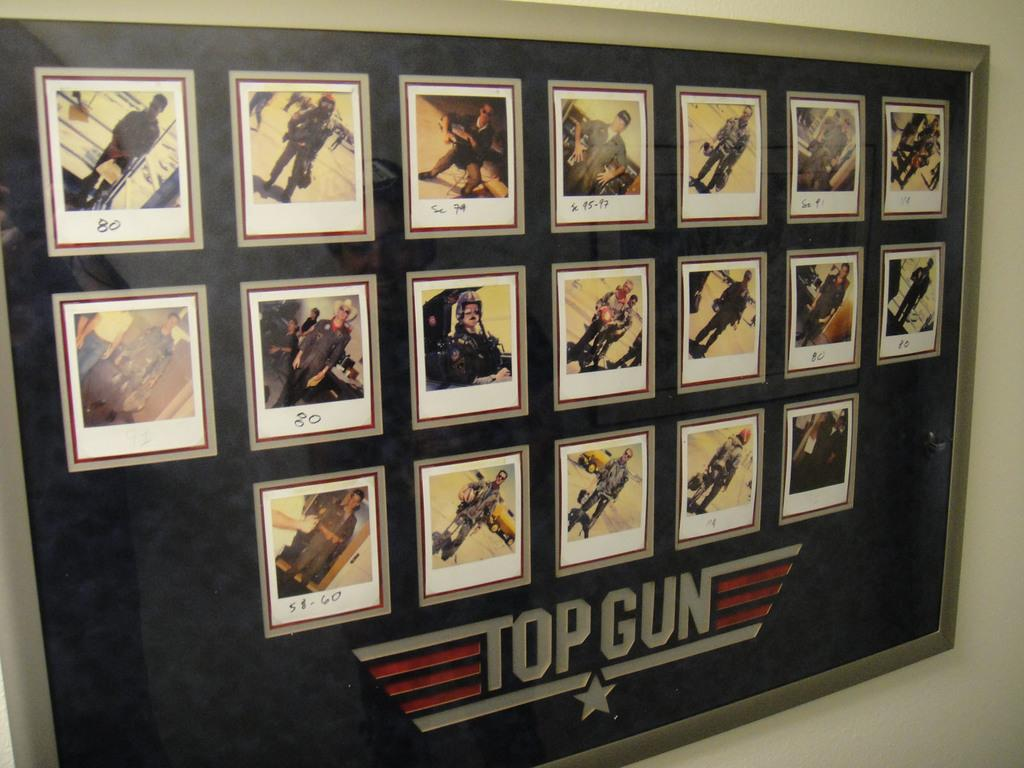<image>
Relay a brief, clear account of the picture shown. All of the main characters are shown in the Top Gun picture. 